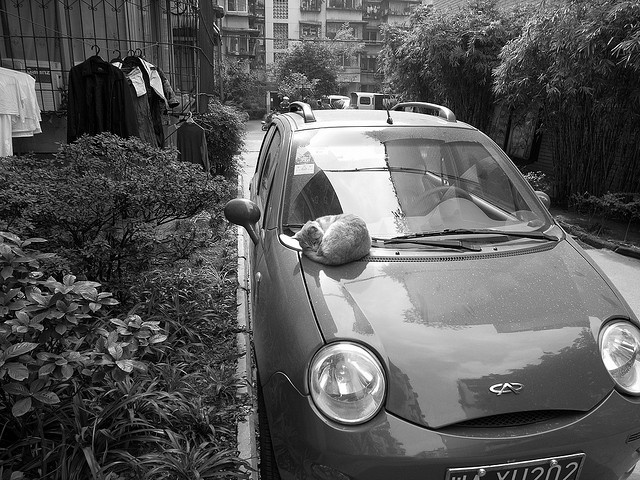Describe the objects in this image and their specific colors. I can see car in black, darkgray, gray, and lightgray tones, cat in black, gray, darkgray, and gainsboro tones, car in black, gray, darkgray, and lightgray tones, and car in black, gray, white, and darkgray tones in this image. 